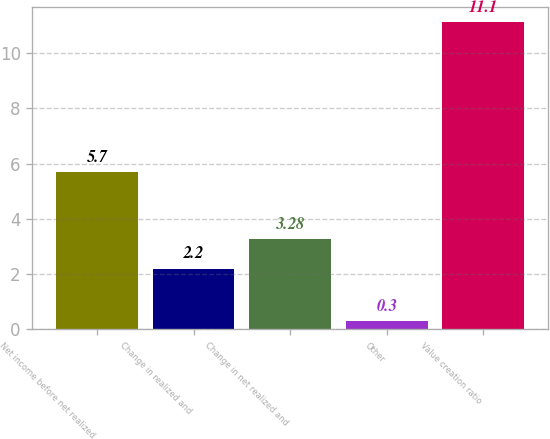Convert chart. <chart><loc_0><loc_0><loc_500><loc_500><bar_chart><fcel>Net income before net realized<fcel>Change in realized and<fcel>Change in net realized and<fcel>Other<fcel>Value creation ratio<nl><fcel>5.7<fcel>2.2<fcel>3.28<fcel>0.3<fcel>11.1<nl></chart> 